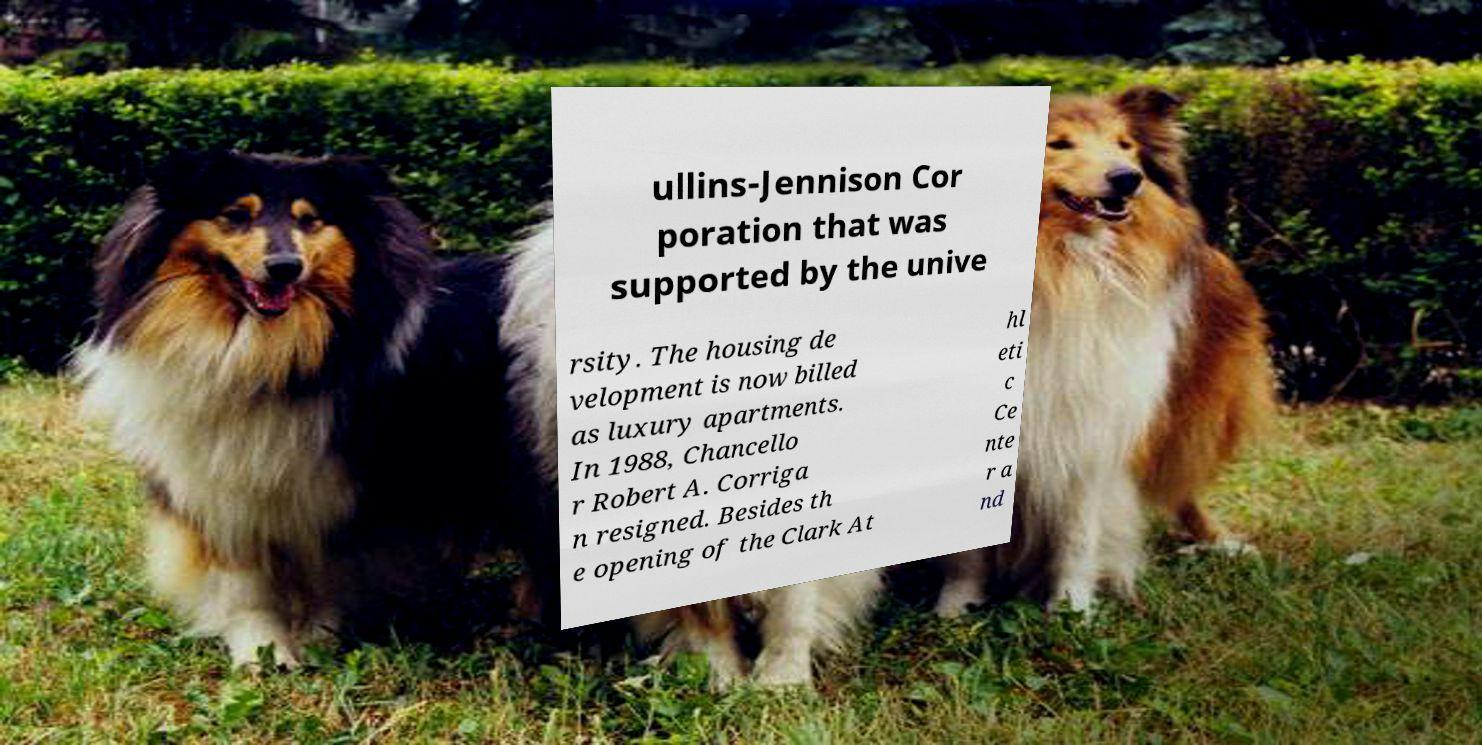For documentation purposes, I need the text within this image transcribed. Could you provide that? ullins-Jennison Cor poration that was supported by the unive rsity. The housing de velopment is now billed as luxury apartments. In 1988, Chancello r Robert A. Corriga n resigned. Besides th e opening of the Clark At hl eti c Ce nte r a nd 